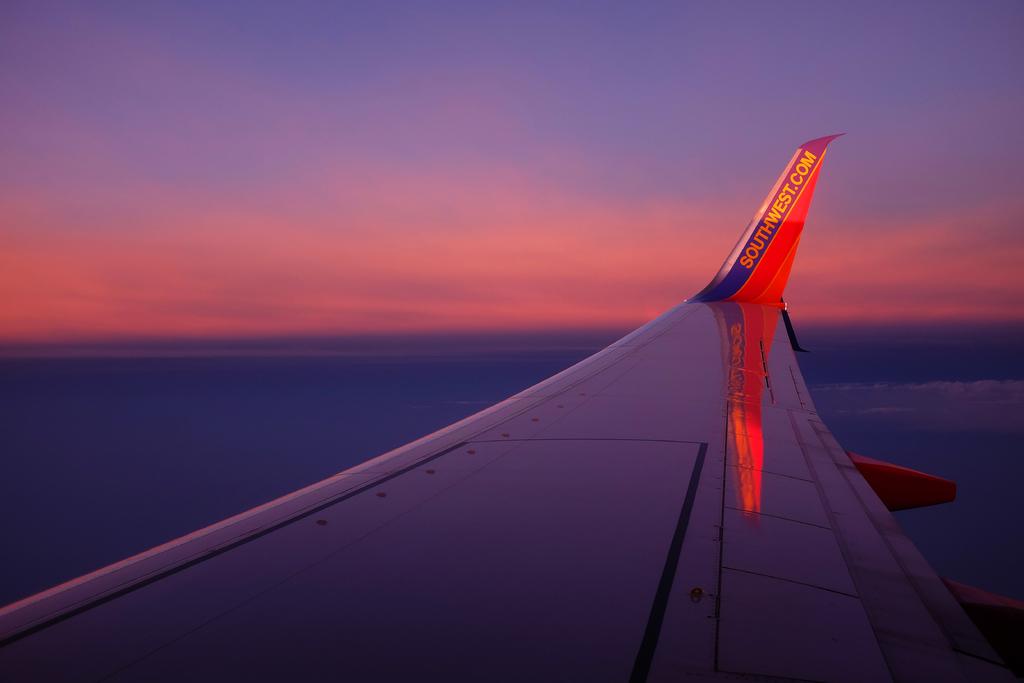What website does the plane advertise?
Offer a very short reply. Southwest.com. What airline is this?
Keep it short and to the point. Southwest. 